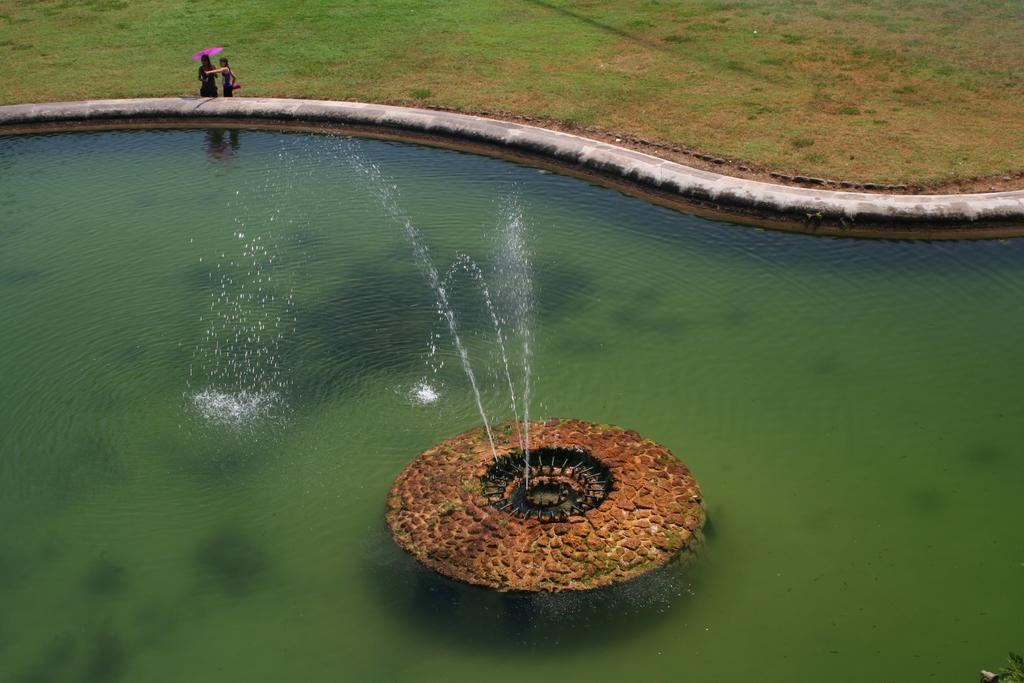In one or two sentences, can you explain what this image depicts? In this image, we can see fountain in the swimming pool and in the background, there are two people and one of them is holding an umbrella and there is ground. 